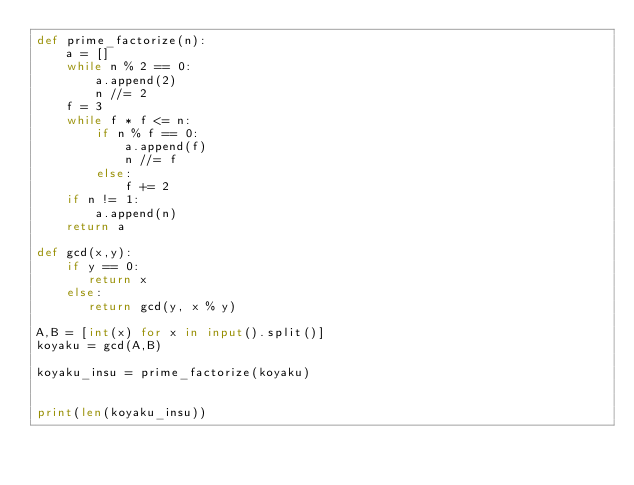<code> <loc_0><loc_0><loc_500><loc_500><_Python_>def prime_factorize(n):
    a = []
    while n % 2 == 0:
        a.append(2)
        n //= 2
    f = 3
    while f * f <= n:
        if n % f == 0:
            a.append(f)
            n //= f
        else:
            f += 2
    if n != 1:
        a.append(n)
    return a
  
def gcd(x,y):
    if y == 0:
       return x
    else:
       return gcd(y, x % y)
 
A,B = [int(x) for x in input().split()]
koyaku = gcd(A,B)
 
koyaku_insu = prime_factorize(koyaku)
 
 
print(len(koyaku_insu))</code> 